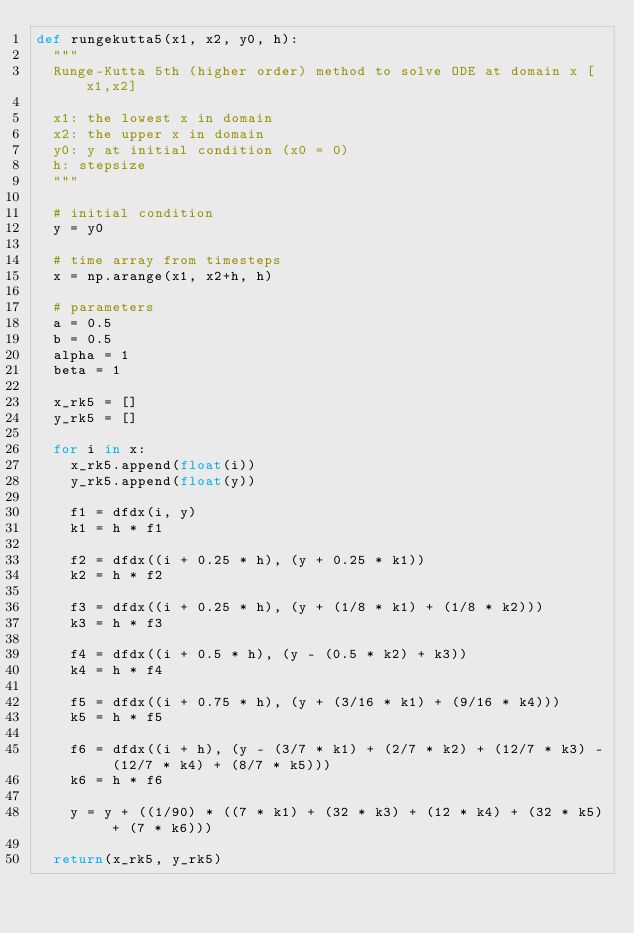<code> <loc_0><loc_0><loc_500><loc_500><_Python_>def rungekutta5(x1, x2, y0, h):
  """
  Runge-Kutta 5th (higher order) method to solve ODE at domain x [x1,x2] 
  
  x1: the lowest x in domain
  x2: the upper x in domain
  y0: y at initial condition (x0 = 0)
  h: stepsize
  """

  # initial condition
  y = y0

  # time array from timesteps
  x = np.arange(x1, x2+h, h)

  # parameters
  a = 0.5
  b = 0.5
  alpha = 1
  beta = 1

  x_rk5 = []
  y_rk5 = []

  for i in x:
    x_rk5.append(float(i))
    y_rk5.append(float(y))

    f1 = dfdx(i, y)
    k1 = h * f1

    f2 = dfdx((i + 0.25 * h), (y + 0.25 * k1))
    k2 = h * f2

    f3 = dfdx((i + 0.25 * h), (y + (1/8 * k1) + (1/8 * k2)))
    k3 = h * f3

    f4 = dfdx((i + 0.5 * h), (y - (0.5 * k2) + k3))
    k4 = h * f4

    f5 = dfdx((i + 0.75 * h), (y + (3/16 * k1) + (9/16 * k4)))
    k5 = h * f5

    f6 = dfdx((i + h), (y - (3/7 * k1) + (2/7 * k2) + (12/7 * k3) - (12/7 * k4) + (8/7 * k5)))
    k6 = h * f6
    
    y = y + ((1/90) * ((7 * k1) + (32 * k3) + (12 * k4) + (32 * k5) + (7 * k6)))

  return(x_rk5, y_rk5)
</code> 